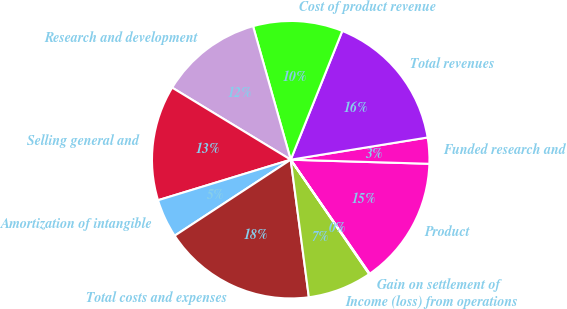Convert chart to OTSL. <chart><loc_0><loc_0><loc_500><loc_500><pie_chart><fcel>Product<fcel>Funded research and<fcel>Total revenues<fcel>Cost of product revenue<fcel>Research and development<fcel>Selling general and<fcel>Amortization of intangible<fcel>Total costs and expenses<fcel>Income (loss) from operations<fcel>Gain on settlement of<nl><fcel>14.89%<fcel>3.03%<fcel>16.37%<fcel>10.44%<fcel>11.93%<fcel>13.41%<fcel>4.51%<fcel>17.86%<fcel>7.48%<fcel>0.07%<nl></chart> 